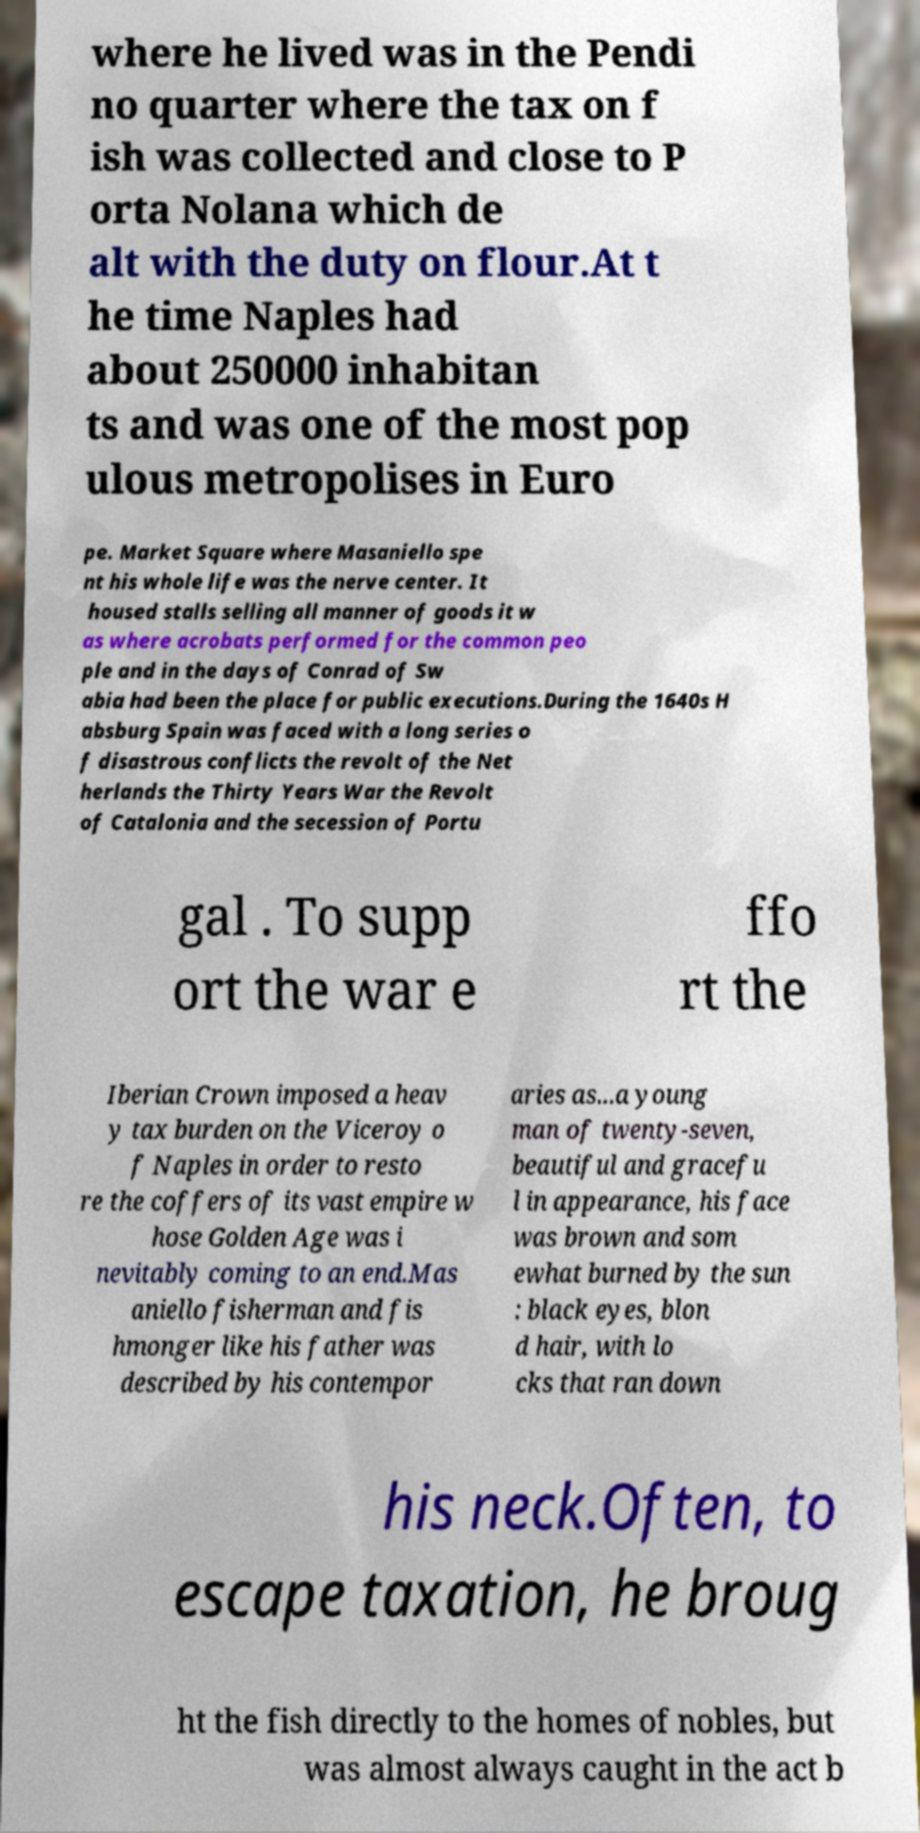For documentation purposes, I need the text within this image transcribed. Could you provide that? where he lived was in the Pendi no quarter where the tax on f ish was collected and close to P orta Nolana which de alt with the duty on flour.At t he time Naples had about 250000 inhabitan ts and was one of the most pop ulous metropolises in Euro pe. Market Square where Masaniello spe nt his whole life was the nerve center. It housed stalls selling all manner of goods it w as where acrobats performed for the common peo ple and in the days of Conrad of Sw abia had been the place for public executions.During the 1640s H absburg Spain was faced with a long series o f disastrous conflicts the revolt of the Net herlands the Thirty Years War the Revolt of Catalonia and the secession of Portu gal . To supp ort the war e ffo rt the Iberian Crown imposed a heav y tax burden on the Viceroy o f Naples in order to resto re the coffers of its vast empire w hose Golden Age was i nevitably coming to an end.Mas aniello fisherman and fis hmonger like his father was described by his contempor aries as...a young man of twenty-seven, beautiful and gracefu l in appearance, his face was brown and som ewhat burned by the sun : black eyes, blon d hair, with lo cks that ran down his neck.Often, to escape taxation, he broug ht the fish directly to the homes of nobles, but was almost always caught in the act b 